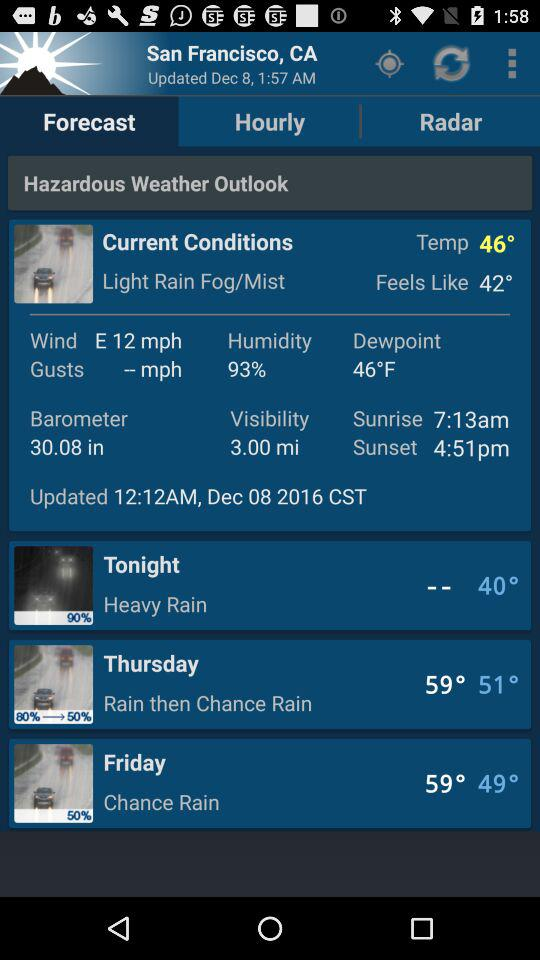What time is the sunrise? The sunrise time is 7:13am. 